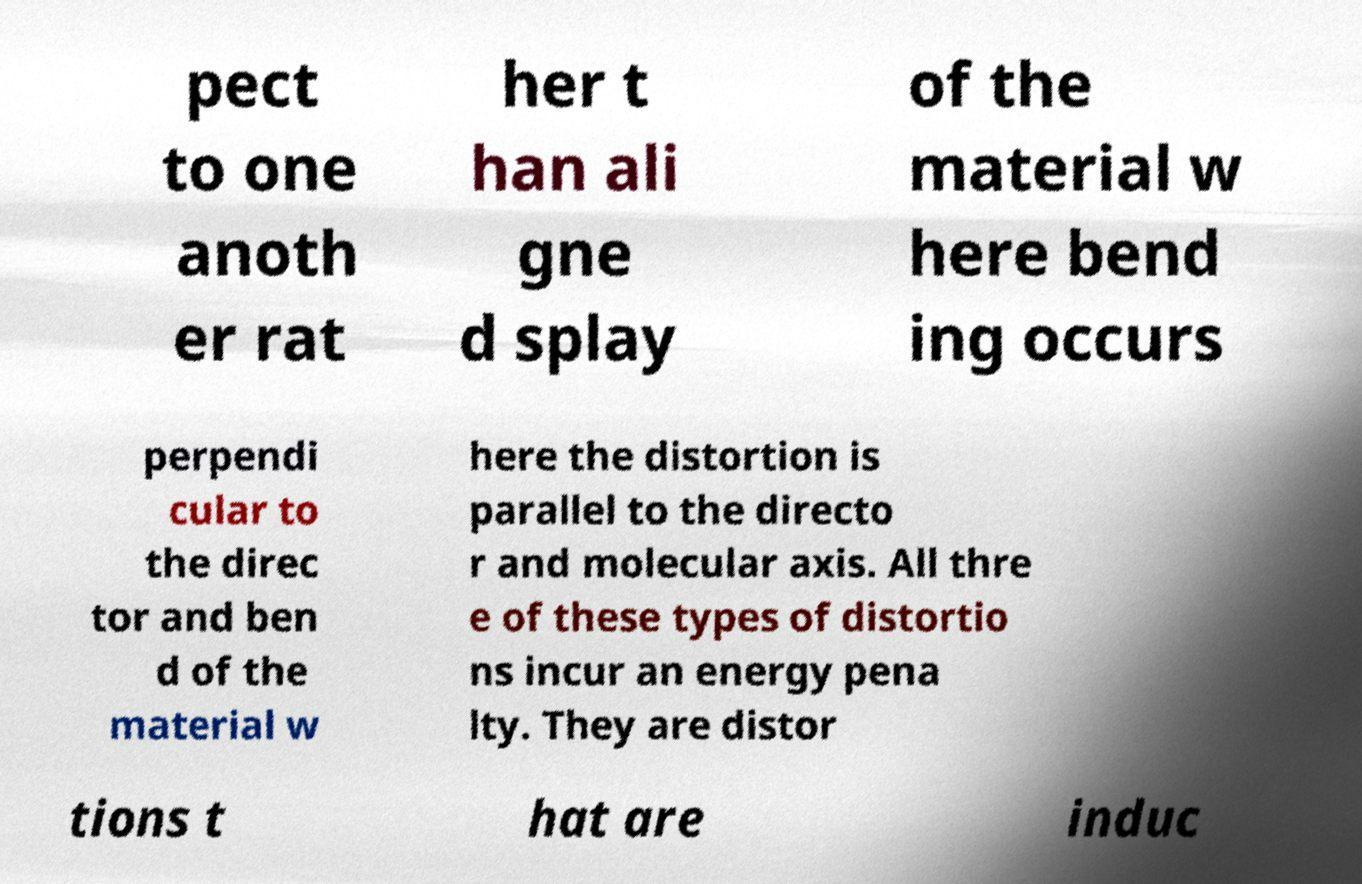Can you read and provide the text displayed in the image?This photo seems to have some interesting text. Can you extract and type it out for me? pect to one anoth er rat her t han ali gne d splay of the material w here bend ing occurs perpendi cular to the direc tor and ben d of the material w here the distortion is parallel to the directo r and molecular axis. All thre e of these types of distortio ns incur an energy pena lty. They are distor tions t hat are induc 